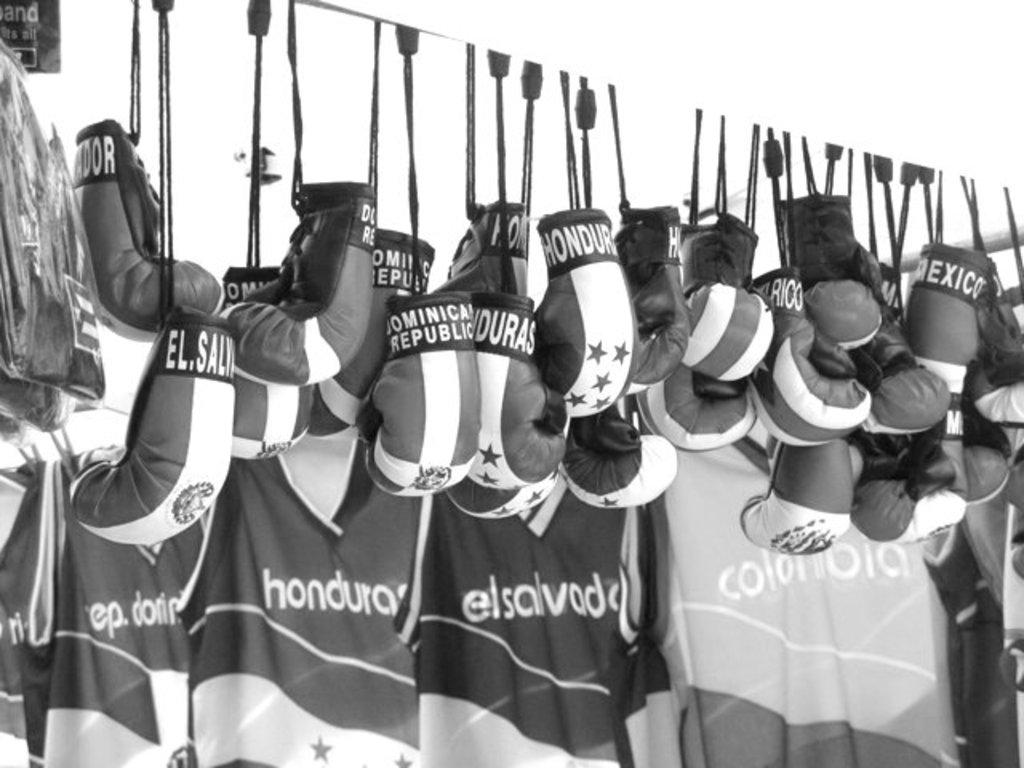Provide a one-sentence caption for the provided image. A black and white picture of various spanish boxing gloves and jerseys hang. 